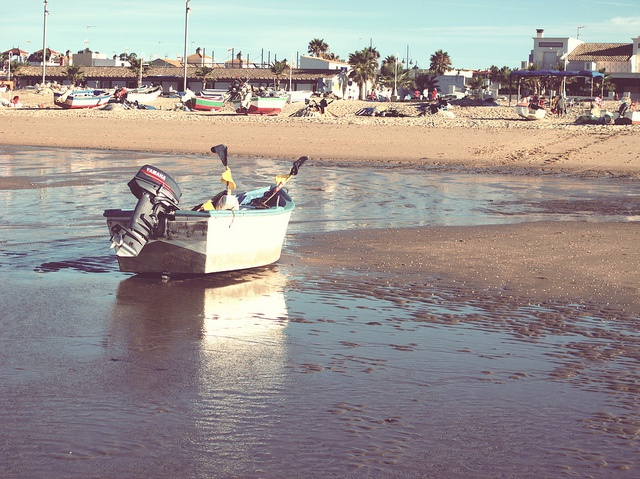Describe the objects in this image and their specific colors. I can see boat in lightblue, beige, gray, darkgray, and purple tones, boat in lightblue, beige, darkgray, and gray tones, boat in lightblue, ivory, purple, and darkgray tones, boat in lightblue, lightgreen, salmon, ivory, and lightpink tones, and boat in lightblue, darkgray, ivory, and purple tones in this image. 